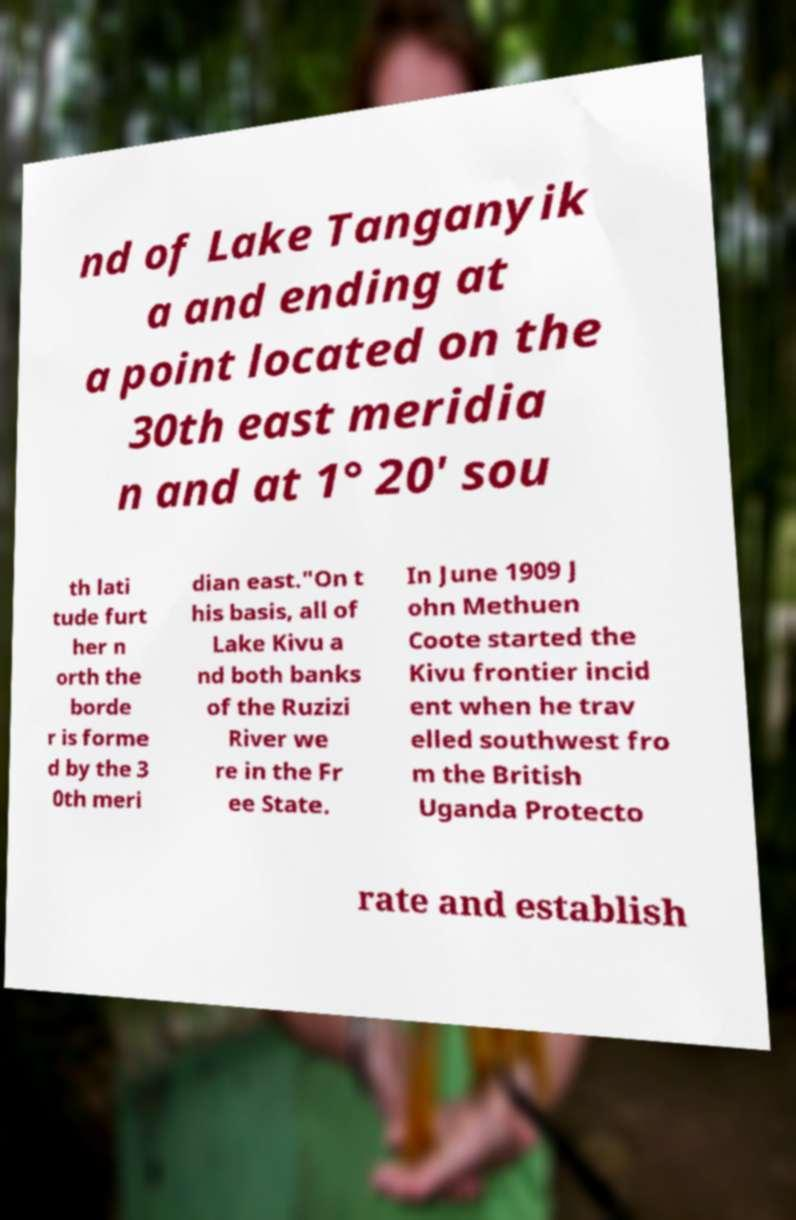Could you assist in decoding the text presented in this image and type it out clearly? nd of Lake Tanganyik a and ending at a point located on the 30th east meridia n and at 1° 20' sou th lati tude furt her n orth the borde r is forme d by the 3 0th meri dian east."On t his basis, all of Lake Kivu a nd both banks of the Ruzizi River we re in the Fr ee State. In June 1909 J ohn Methuen Coote started the Kivu frontier incid ent when he trav elled southwest fro m the British Uganda Protecto rate and establish 